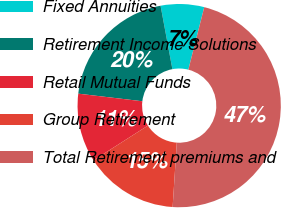Convert chart to OTSL. <chart><loc_0><loc_0><loc_500><loc_500><pie_chart><fcel>Fixed Annuities<fcel>Retirement Income Solutions<fcel>Retail Mutual Funds<fcel>Group Retirement<fcel>Total Retirement premiums and<nl><fcel>6.9%<fcel>20.19%<fcel>10.92%<fcel>14.93%<fcel>47.06%<nl></chart> 